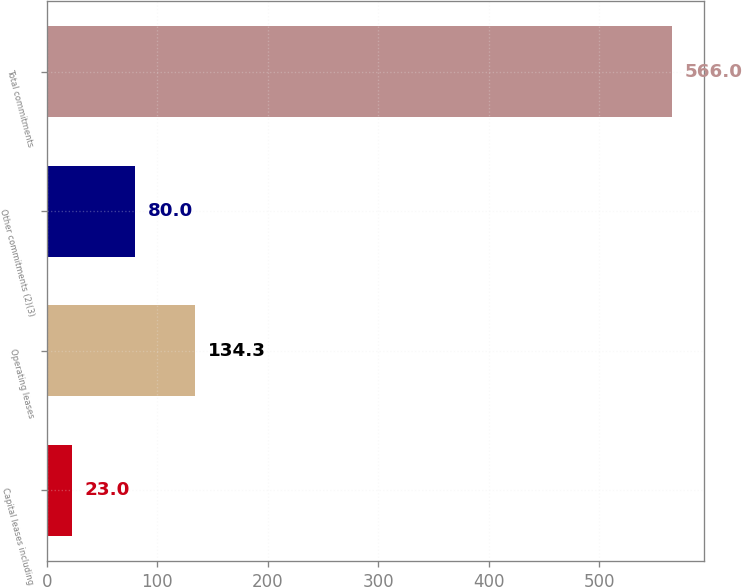Convert chart to OTSL. <chart><loc_0><loc_0><loc_500><loc_500><bar_chart><fcel>Capital leases including<fcel>Operating leases<fcel>Other commitments (2)(3)<fcel>Total commitments<nl><fcel>23<fcel>134.3<fcel>80<fcel>566<nl></chart> 